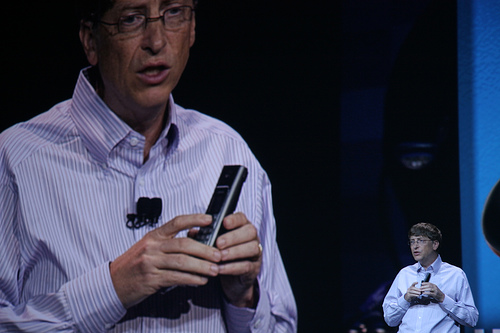<image>
Can you confirm if the man is under the remote? No. The man is not positioned under the remote. The vertical relationship between these objects is different. 